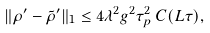<formula> <loc_0><loc_0><loc_500><loc_500>\| \rho ^ { \prime } - \tilde { \rho } ^ { \prime } \| _ { 1 } \leq 4 \lambda ^ { 2 } g ^ { 2 } \tau _ { p } ^ { 2 } \, C ( L \tau ) ,</formula> 